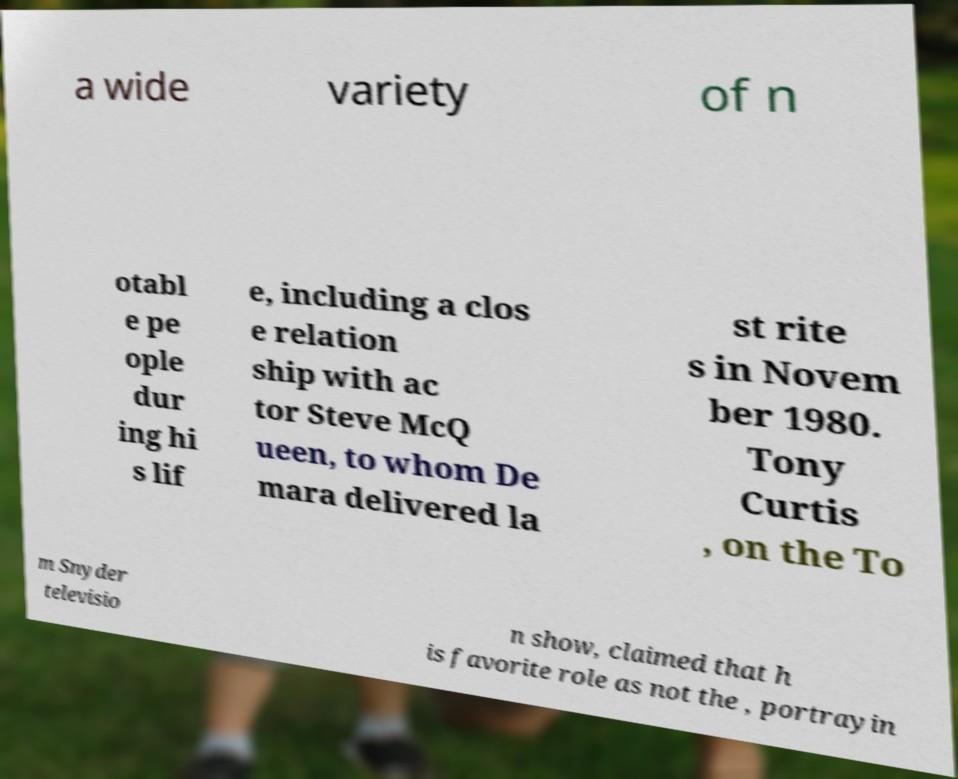Please identify and transcribe the text found in this image. a wide variety of n otabl e pe ople dur ing hi s lif e, including a clos e relation ship with ac tor Steve McQ ueen, to whom De mara delivered la st rite s in Novem ber 1980. Tony Curtis , on the To m Snyder televisio n show, claimed that h is favorite role as not the , portrayin 